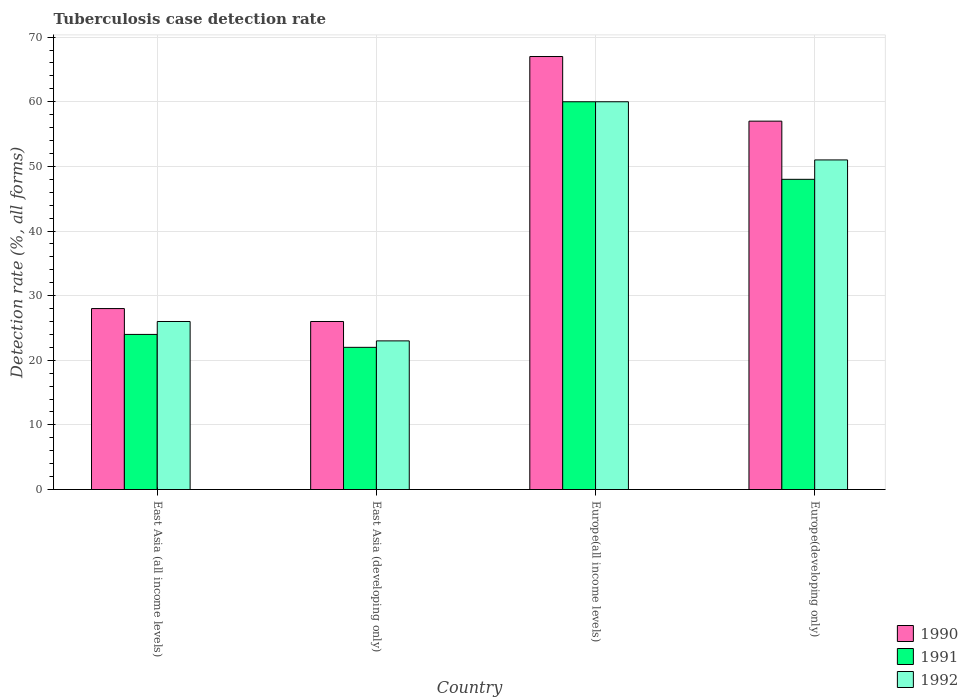How many different coloured bars are there?
Your response must be concise. 3. How many groups of bars are there?
Keep it short and to the point. 4. Are the number of bars per tick equal to the number of legend labels?
Provide a short and direct response. Yes. Are the number of bars on each tick of the X-axis equal?
Keep it short and to the point. Yes. How many bars are there on the 1st tick from the right?
Offer a terse response. 3. What is the label of the 4th group of bars from the left?
Ensure brevity in your answer.  Europe(developing only). Across all countries, what is the minimum tuberculosis case detection rate in in 1991?
Offer a very short reply. 22. In which country was the tuberculosis case detection rate in in 1990 maximum?
Offer a terse response. Europe(all income levels). In which country was the tuberculosis case detection rate in in 1992 minimum?
Keep it short and to the point. East Asia (developing only). What is the total tuberculosis case detection rate in in 1991 in the graph?
Your response must be concise. 154. What is the difference between the tuberculosis case detection rate in in 1990 in East Asia (all income levels) and that in East Asia (developing only)?
Give a very brief answer. 2. What is the average tuberculosis case detection rate in in 1991 per country?
Provide a short and direct response. 38.5. What is the ratio of the tuberculosis case detection rate in in 1992 in East Asia (all income levels) to that in Europe(all income levels)?
Keep it short and to the point. 0.43. Is the tuberculosis case detection rate in in 1990 in East Asia (developing only) less than that in Europe(developing only)?
Your response must be concise. Yes. What is the difference between the highest and the second highest tuberculosis case detection rate in in 1991?
Offer a terse response. 24. In how many countries, is the tuberculosis case detection rate in in 1991 greater than the average tuberculosis case detection rate in in 1991 taken over all countries?
Your response must be concise. 2. Is the sum of the tuberculosis case detection rate in in 1991 in Europe(all income levels) and Europe(developing only) greater than the maximum tuberculosis case detection rate in in 1990 across all countries?
Provide a succinct answer. Yes. What does the 1st bar from the left in Europe(developing only) represents?
Your answer should be compact. 1990. What does the 2nd bar from the right in Europe(developing only) represents?
Give a very brief answer. 1991. Is it the case that in every country, the sum of the tuberculosis case detection rate in in 1990 and tuberculosis case detection rate in in 1991 is greater than the tuberculosis case detection rate in in 1992?
Offer a terse response. Yes. How many bars are there?
Offer a very short reply. 12. Are all the bars in the graph horizontal?
Your answer should be compact. No. What is the difference between two consecutive major ticks on the Y-axis?
Keep it short and to the point. 10. Does the graph contain grids?
Offer a terse response. Yes. How are the legend labels stacked?
Provide a succinct answer. Vertical. What is the title of the graph?
Provide a short and direct response. Tuberculosis case detection rate. What is the label or title of the X-axis?
Provide a short and direct response. Country. What is the label or title of the Y-axis?
Provide a succinct answer. Detection rate (%, all forms). What is the Detection rate (%, all forms) in 1990 in East Asia (developing only)?
Offer a very short reply. 26. What is the Detection rate (%, all forms) in 1991 in Europe(all income levels)?
Make the answer very short. 60. What is the Detection rate (%, all forms) in 1991 in Europe(developing only)?
Your answer should be compact. 48. What is the Detection rate (%, all forms) of 1992 in Europe(developing only)?
Ensure brevity in your answer.  51. Across all countries, what is the maximum Detection rate (%, all forms) of 1991?
Provide a succinct answer. 60. Across all countries, what is the minimum Detection rate (%, all forms) in 1990?
Offer a very short reply. 26. Across all countries, what is the minimum Detection rate (%, all forms) in 1991?
Ensure brevity in your answer.  22. What is the total Detection rate (%, all forms) in 1990 in the graph?
Keep it short and to the point. 178. What is the total Detection rate (%, all forms) of 1991 in the graph?
Your answer should be compact. 154. What is the total Detection rate (%, all forms) in 1992 in the graph?
Provide a short and direct response. 160. What is the difference between the Detection rate (%, all forms) in 1990 in East Asia (all income levels) and that in East Asia (developing only)?
Your response must be concise. 2. What is the difference between the Detection rate (%, all forms) of 1991 in East Asia (all income levels) and that in East Asia (developing only)?
Make the answer very short. 2. What is the difference between the Detection rate (%, all forms) of 1992 in East Asia (all income levels) and that in East Asia (developing only)?
Make the answer very short. 3. What is the difference between the Detection rate (%, all forms) in 1990 in East Asia (all income levels) and that in Europe(all income levels)?
Your answer should be compact. -39. What is the difference between the Detection rate (%, all forms) in 1991 in East Asia (all income levels) and that in Europe(all income levels)?
Give a very brief answer. -36. What is the difference between the Detection rate (%, all forms) in 1992 in East Asia (all income levels) and that in Europe(all income levels)?
Keep it short and to the point. -34. What is the difference between the Detection rate (%, all forms) in 1991 in East Asia (all income levels) and that in Europe(developing only)?
Your answer should be compact. -24. What is the difference between the Detection rate (%, all forms) of 1992 in East Asia (all income levels) and that in Europe(developing only)?
Ensure brevity in your answer.  -25. What is the difference between the Detection rate (%, all forms) in 1990 in East Asia (developing only) and that in Europe(all income levels)?
Your answer should be compact. -41. What is the difference between the Detection rate (%, all forms) of 1991 in East Asia (developing only) and that in Europe(all income levels)?
Your response must be concise. -38. What is the difference between the Detection rate (%, all forms) of 1992 in East Asia (developing only) and that in Europe(all income levels)?
Provide a short and direct response. -37. What is the difference between the Detection rate (%, all forms) in 1990 in East Asia (developing only) and that in Europe(developing only)?
Offer a terse response. -31. What is the difference between the Detection rate (%, all forms) in 1991 in East Asia (developing only) and that in Europe(developing only)?
Provide a short and direct response. -26. What is the difference between the Detection rate (%, all forms) in 1992 in East Asia (developing only) and that in Europe(developing only)?
Your answer should be very brief. -28. What is the difference between the Detection rate (%, all forms) in 1991 in Europe(all income levels) and that in Europe(developing only)?
Make the answer very short. 12. What is the difference between the Detection rate (%, all forms) in 1990 in East Asia (all income levels) and the Detection rate (%, all forms) in 1991 in East Asia (developing only)?
Offer a very short reply. 6. What is the difference between the Detection rate (%, all forms) of 1990 in East Asia (all income levels) and the Detection rate (%, all forms) of 1991 in Europe(all income levels)?
Provide a short and direct response. -32. What is the difference between the Detection rate (%, all forms) in 1990 in East Asia (all income levels) and the Detection rate (%, all forms) in 1992 in Europe(all income levels)?
Ensure brevity in your answer.  -32. What is the difference between the Detection rate (%, all forms) of 1991 in East Asia (all income levels) and the Detection rate (%, all forms) of 1992 in Europe(all income levels)?
Offer a terse response. -36. What is the difference between the Detection rate (%, all forms) in 1990 in East Asia (developing only) and the Detection rate (%, all forms) in 1991 in Europe(all income levels)?
Keep it short and to the point. -34. What is the difference between the Detection rate (%, all forms) in 1990 in East Asia (developing only) and the Detection rate (%, all forms) in 1992 in Europe(all income levels)?
Make the answer very short. -34. What is the difference between the Detection rate (%, all forms) in 1991 in East Asia (developing only) and the Detection rate (%, all forms) in 1992 in Europe(all income levels)?
Ensure brevity in your answer.  -38. What is the difference between the Detection rate (%, all forms) in 1990 in East Asia (developing only) and the Detection rate (%, all forms) in 1991 in Europe(developing only)?
Give a very brief answer. -22. What is the difference between the Detection rate (%, all forms) of 1991 in East Asia (developing only) and the Detection rate (%, all forms) of 1992 in Europe(developing only)?
Provide a succinct answer. -29. What is the difference between the Detection rate (%, all forms) of 1990 in Europe(all income levels) and the Detection rate (%, all forms) of 1991 in Europe(developing only)?
Provide a succinct answer. 19. What is the average Detection rate (%, all forms) of 1990 per country?
Your answer should be very brief. 44.5. What is the average Detection rate (%, all forms) in 1991 per country?
Your answer should be compact. 38.5. What is the average Detection rate (%, all forms) in 1992 per country?
Offer a very short reply. 40. What is the difference between the Detection rate (%, all forms) of 1990 and Detection rate (%, all forms) of 1991 in East Asia (developing only)?
Your answer should be compact. 4. What is the difference between the Detection rate (%, all forms) in 1991 and Detection rate (%, all forms) in 1992 in East Asia (developing only)?
Your response must be concise. -1. What is the difference between the Detection rate (%, all forms) in 1990 and Detection rate (%, all forms) in 1991 in Europe(all income levels)?
Make the answer very short. 7. What is the difference between the Detection rate (%, all forms) of 1990 and Detection rate (%, all forms) of 1992 in Europe(all income levels)?
Make the answer very short. 7. What is the difference between the Detection rate (%, all forms) in 1991 and Detection rate (%, all forms) in 1992 in Europe(all income levels)?
Your response must be concise. 0. What is the difference between the Detection rate (%, all forms) of 1990 and Detection rate (%, all forms) of 1991 in Europe(developing only)?
Give a very brief answer. 9. What is the ratio of the Detection rate (%, all forms) of 1992 in East Asia (all income levels) to that in East Asia (developing only)?
Your answer should be very brief. 1.13. What is the ratio of the Detection rate (%, all forms) in 1990 in East Asia (all income levels) to that in Europe(all income levels)?
Make the answer very short. 0.42. What is the ratio of the Detection rate (%, all forms) of 1992 in East Asia (all income levels) to that in Europe(all income levels)?
Keep it short and to the point. 0.43. What is the ratio of the Detection rate (%, all forms) of 1990 in East Asia (all income levels) to that in Europe(developing only)?
Ensure brevity in your answer.  0.49. What is the ratio of the Detection rate (%, all forms) in 1991 in East Asia (all income levels) to that in Europe(developing only)?
Keep it short and to the point. 0.5. What is the ratio of the Detection rate (%, all forms) in 1992 in East Asia (all income levels) to that in Europe(developing only)?
Provide a short and direct response. 0.51. What is the ratio of the Detection rate (%, all forms) in 1990 in East Asia (developing only) to that in Europe(all income levels)?
Provide a short and direct response. 0.39. What is the ratio of the Detection rate (%, all forms) in 1991 in East Asia (developing only) to that in Europe(all income levels)?
Keep it short and to the point. 0.37. What is the ratio of the Detection rate (%, all forms) of 1992 in East Asia (developing only) to that in Europe(all income levels)?
Your answer should be very brief. 0.38. What is the ratio of the Detection rate (%, all forms) in 1990 in East Asia (developing only) to that in Europe(developing only)?
Provide a succinct answer. 0.46. What is the ratio of the Detection rate (%, all forms) in 1991 in East Asia (developing only) to that in Europe(developing only)?
Your answer should be compact. 0.46. What is the ratio of the Detection rate (%, all forms) of 1992 in East Asia (developing only) to that in Europe(developing only)?
Provide a short and direct response. 0.45. What is the ratio of the Detection rate (%, all forms) of 1990 in Europe(all income levels) to that in Europe(developing only)?
Make the answer very short. 1.18. What is the ratio of the Detection rate (%, all forms) of 1991 in Europe(all income levels) to that in Europe(developing only)?
Your answer should be compact. 1.25. What is the ratio of the Detection rate (%, all forms) in 1992 in Europe(all income levels) to that in Europe(developing only)?
Your answer should be compact. 1.18. What is the difference between the highest and the second highest Detection rate (%, all forms) in 1991?
Your response must be concise. 12. What is the difference between the highest and the second highest Detection rate (%, all forms) in 1992?
Give a very brief answer. 9. What is the difference between the highest and the lowest Detection rate (%, all forms) of 1990?
Your response must be concise. 41. What is the difference between the highest and the lowest Detection rate (%, all forms) of 1991?
Your response must be concise. 38. What is the difference between the highest and the lowest Detection rate (%, all forms) of 1992?
Offer a terse response. 37. 